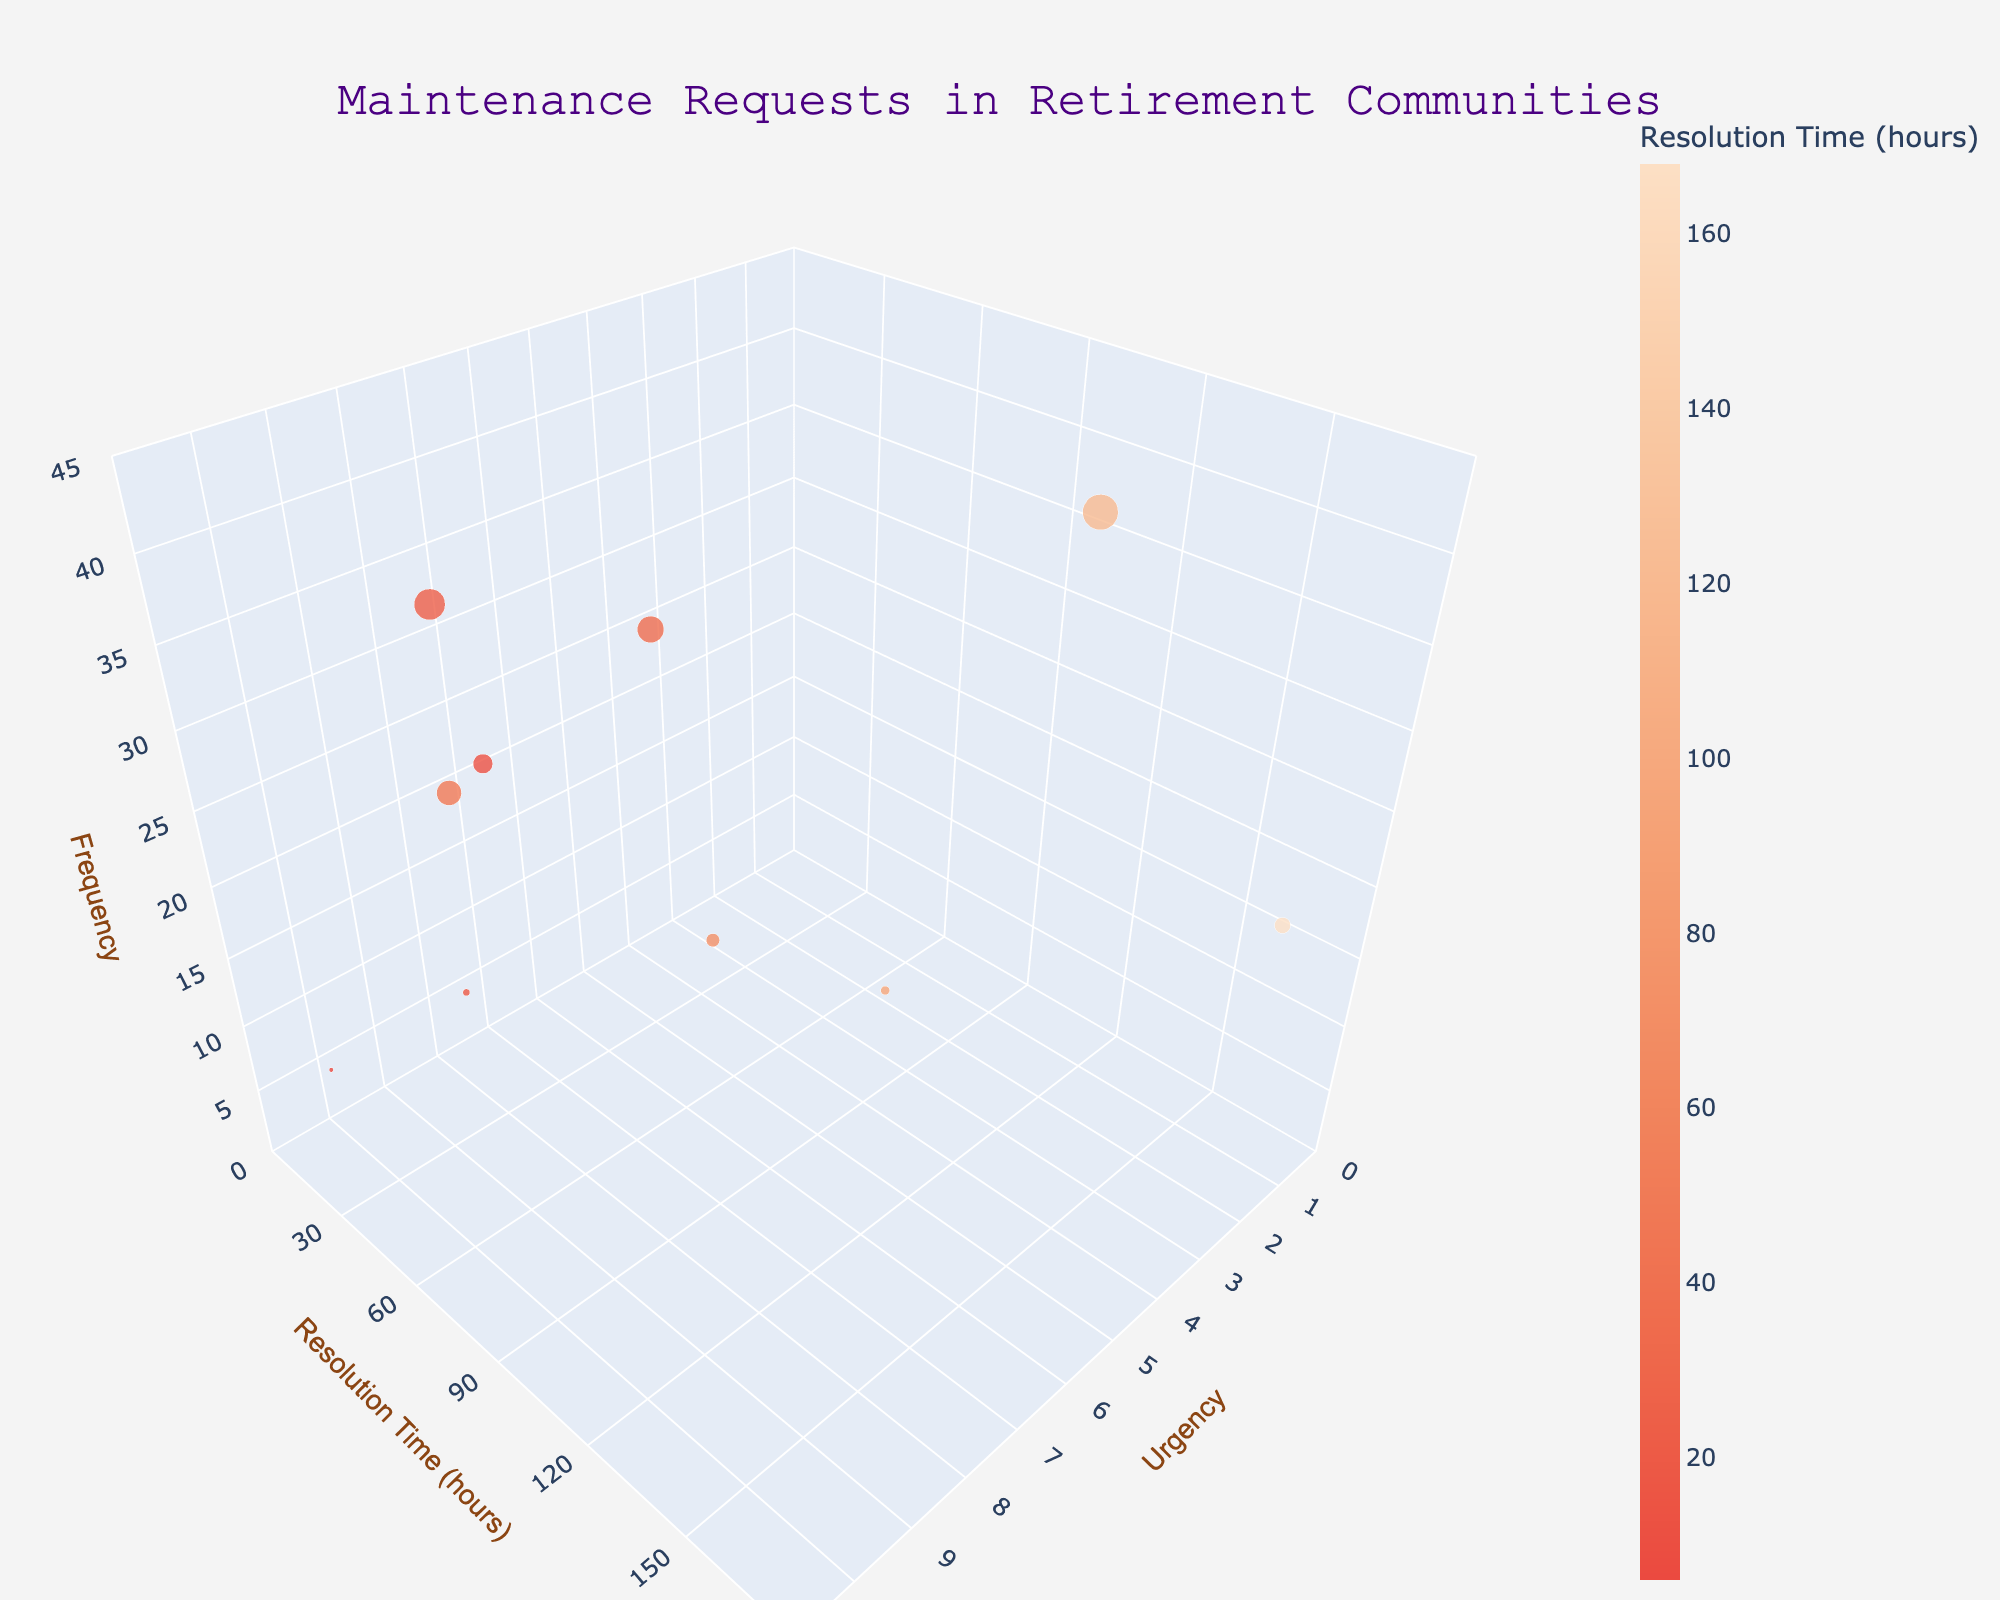What's the title of the figure? Look at the top of the chart where the text is presented in large font enclosed within quotation marks. It reads "Maintenance Requests in Retirement Communities".
Answer: Maintenance Requests in Retirement Communities How many different types of maintenance requests are plotted in the figure? By counting the number of distinct points floating in the 3D space, we can see there are 10 points, each representing a different maintenance request type.
Answer: 10 What is the range of urgency values? Inspect the X-axis labeled "Urgency". The axis ticks range from 0 to 10.
Answer: 0 to 10 Which type of maintenance request has the shortest average resolution time? Find the lowest value on the Y-axis (Resolution Time in hours) and identify which data point (bubble) corresponds to this value. The text label for this data point will reveal that "Elevator Maintenance" has the shortest resolution time of 6 hours.
Answer: Elevator Maintenance Which maintenance request type has the largest frequency? Identify the largest bubble in space because the bubble size represents frequency. This corresponds to "Lawn Care" which has a frequency of 40.
Answer: Lawn Care What is the urgency level of electrical problems? Locate "Electrical Problems" in the text labels of the bubbles and see where it falls on the X-axis. This shows an urgency level of 7.
Answer: 7 What is the average resolution time for plumbing issues? Find the "Plumbing Issues" bubble label and check the corresponding Y-axis value for resolution time, which is 24 hours.
Answer: 24 hours What is the average resolution time of requests with an urgency of 8? Identify data points with an urgency value of 8 by looking at bubbles along the Urgency value of 8 on the X-axis. "Plumbing Issues" is at 24 hours and "Security System Issues" is at 18 hours. The average is calculated as (24 + 18) / 2 = 21 hours.
Answer: 21 hours Compare the frequency of HVAC malfunctions and applinace repairs. Which one is higher? Locate both "HVAC Malfunctions" and "Appliance Repairs" along with their corresponding bubble sizes. HVAC Malfunctions has a frequency of 28 while Appliance Repairs has 30, making Appliance Repairs higher.
Answer: Appliance Repairs Which maintenance request types have an urgency level greater than 8? Look for bubbles with text labels above the 8 mark on the X-axis. The requests are "HVAC Malfunctions" (9) and "Elevator Maintenance" (10).
Answer: HVAC Malfunctions, Elevator Maintenance 